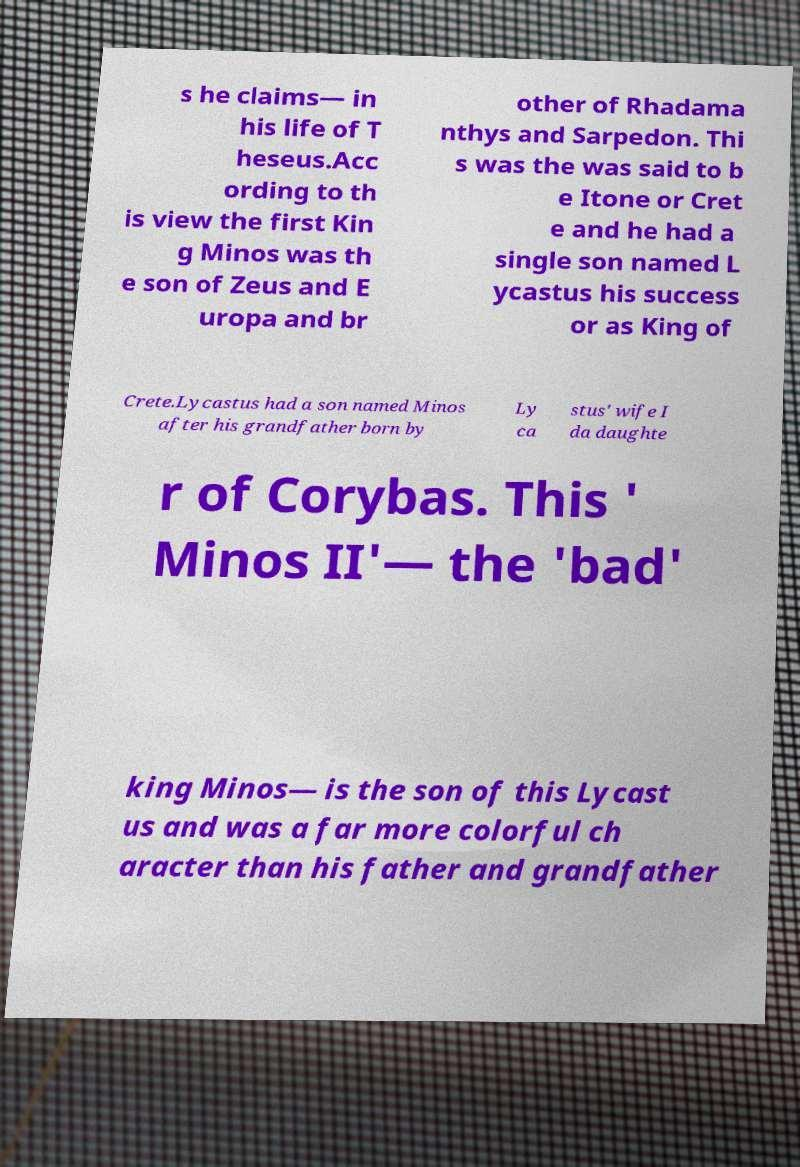I need the written content from this picture converted into text. Can you do that? s he claims— in his life of T heseus.Acc ording to th is view the first Kin g Minos was th e son of Zeus and E uropa and br other of Rhadama nthys and Sarpedon. Thi s was the was said to b e Itone or Cret e and he had a single son named L ycastus his success or as King of Crete.Lycastus had a son named Minos after his grandfather born by Ly ca stus' wife I da daughte r of Corybas. This ' Minos II'— the 'bad' king Minos— is the son of this Lycast us and was a far more colorful ch aracter than his father and grandfather 